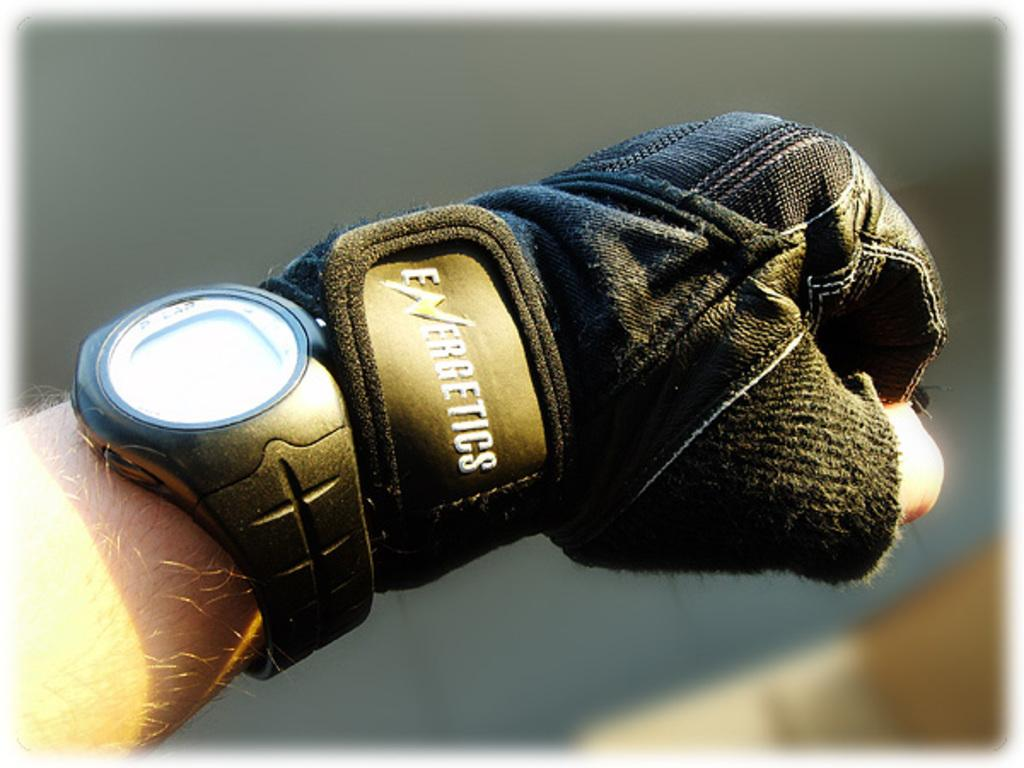What part of the person is visible in the image? There is a person's hand in the image. What is the person wearing on their hand? The person is wearing a hand glove. What accessory is visible on the person's hand? The person is wearing a watch. Can you see any fangs on the person's hand in the image? There are no fangs visible on the person's hand in the image. 